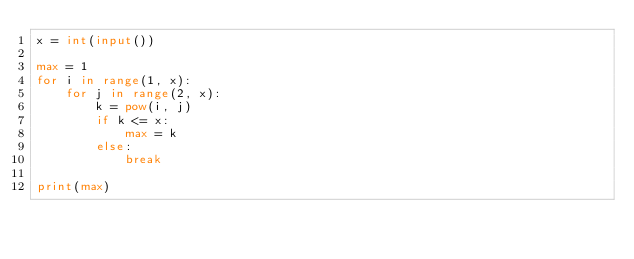Convert code to text. <code><loc_0><loc_0><loc_500><loc_500><_Python_>x = int(input())

max = 1
for i in range(1, x):
    for j in range(2, x):
        k = pow(i, j)
        if k <= x:
            max = k
        else:
            break

print(max)</code> 